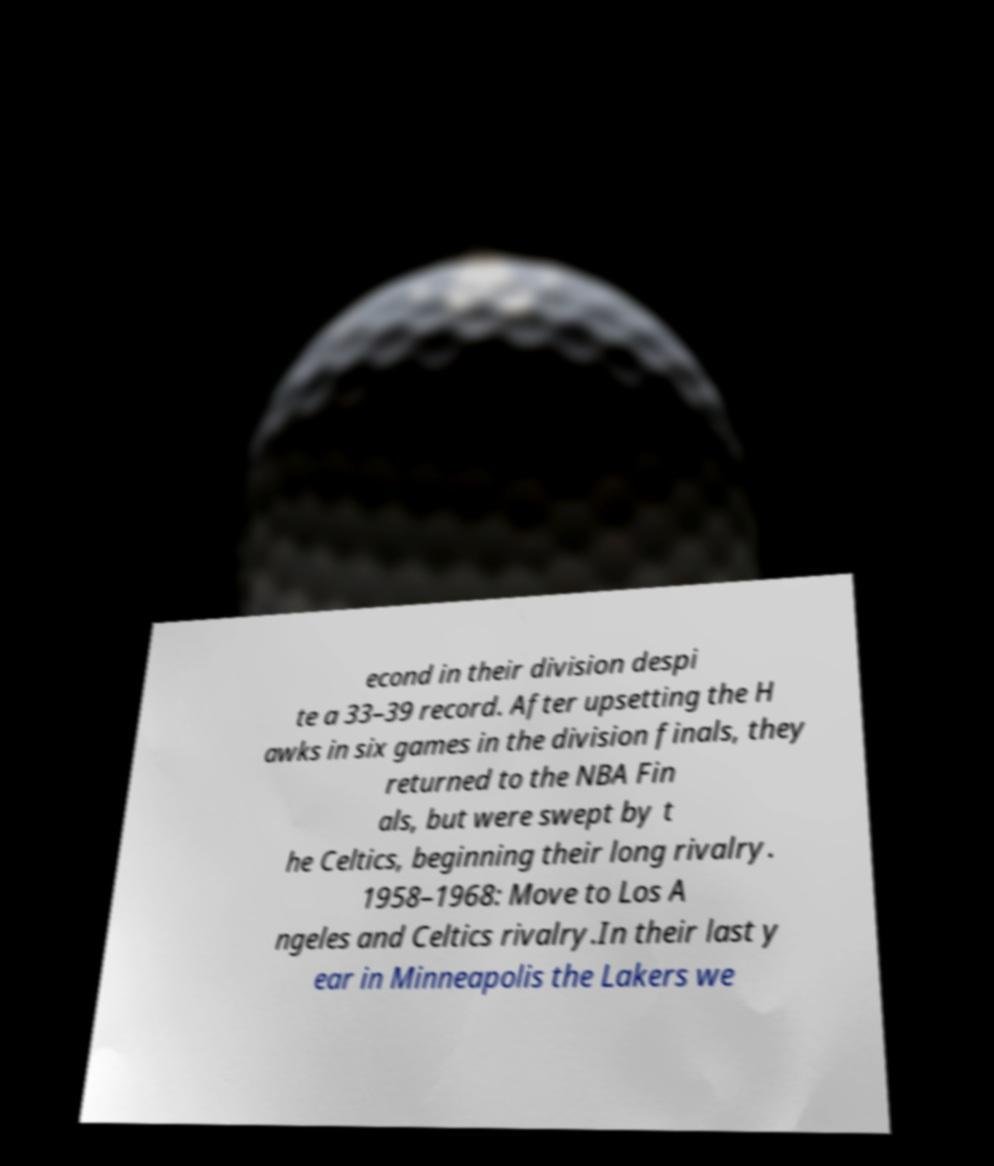Can you accurately transcribe the text from the provided image for me? econd in their division despi te a 33–39 record. After upsetting the H awks in six games in the division finals, they returned to the NBA Fin als, but were swept by t he Celtics, beginning their long rivalry. 1958–1968: Move to Los A ngeles and Celtics rivalry.In their last y ear in Minneapolis the Lakers we 